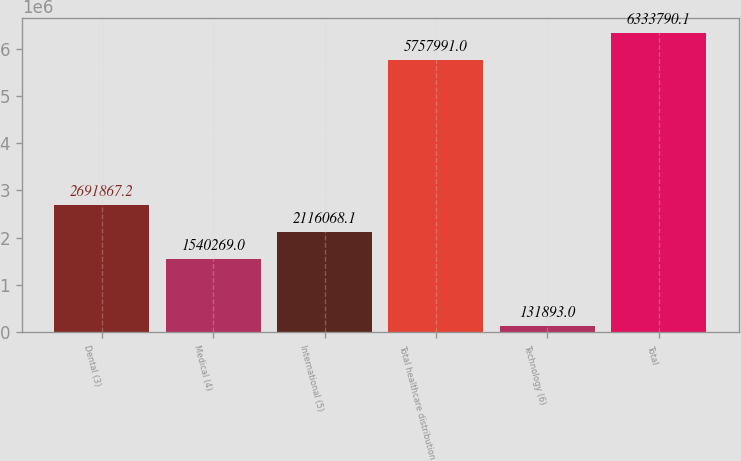Convert chart to OTSL. <chart><loc_0><loc_0><loc_500><loc_500><bar_chart><fcel>Dental (3)<fcel>Medical (4)<fcel>International (5)<fcel>Total healthcare distribution<fcel>Technology (6)<fcel>Total<nl><fcel>2.69187e+06<fcel>1.54027e+06<fcel>2.11607e+06<fcel>5.75799e+06<fcel>131893<fcel>6.33379e+06<nl></chart> 